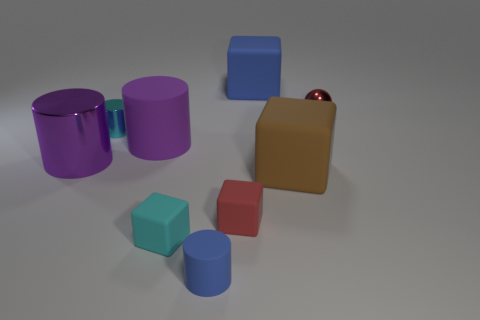Can you describe the arrangement of the objects closest to the small red cube? Certainly! To the right of the small red cube, there is a small blue cube, and directly behind the red cube, there is a brown cube. A small metallic sphere is also visible to the right, placed a bit further away from the group of cubes. 